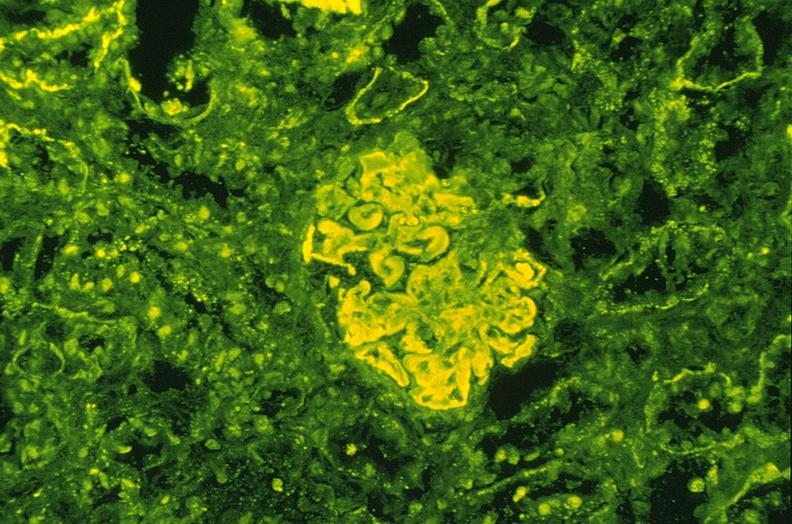where is this?
Answer the question using a single word or phrase. Urinary 